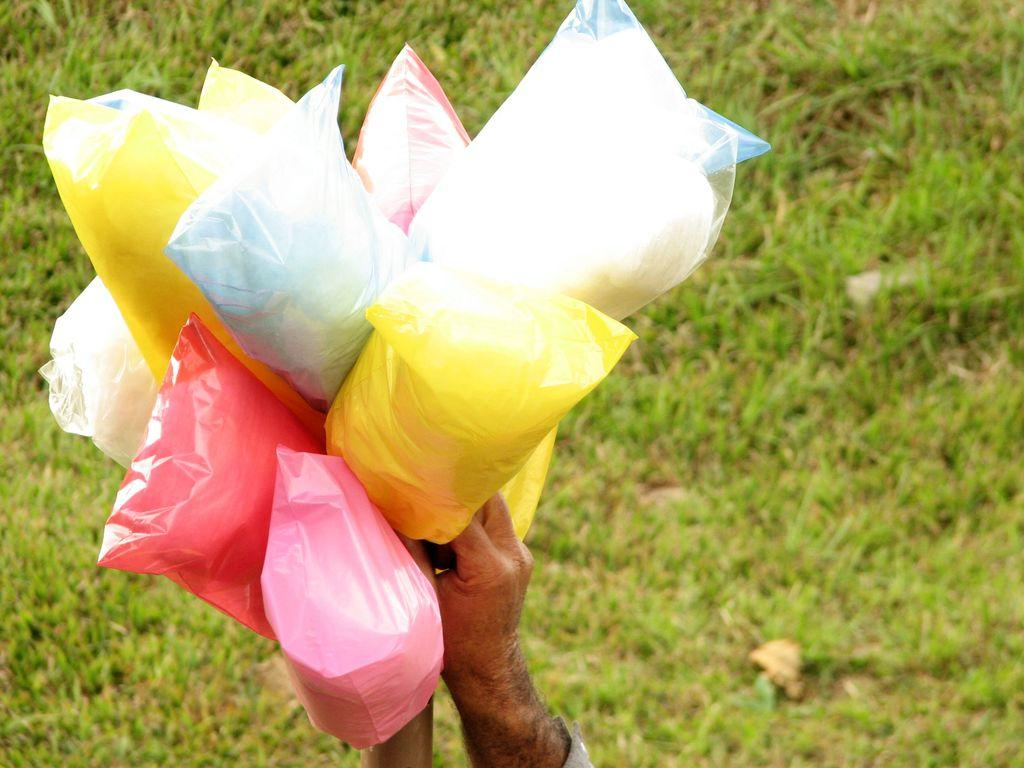What is being held by the person's hands in the image? There are person's hands holding plastic covers in the image. What can be seen inside the plastic covers? The plastic covers contain different colors. What type of natural environment is visible in the image? There is grass visible in the image. What type of bread can be seen in the image? There is no bread present in the image. 